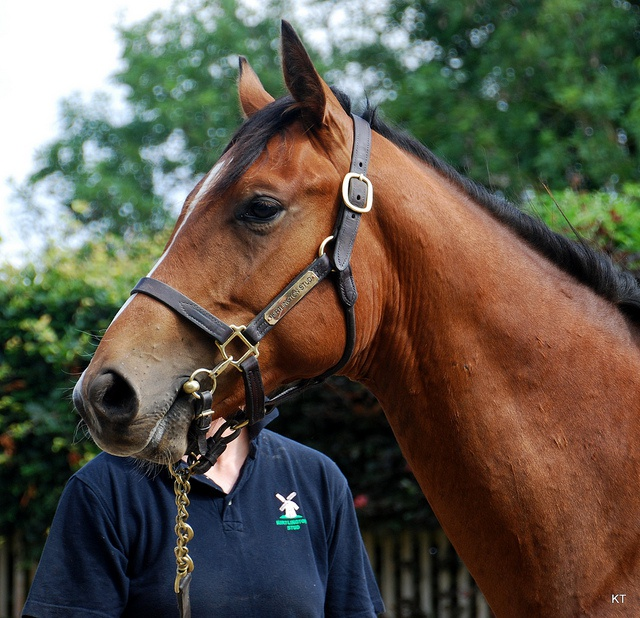Describe the objects in this image and their specific colors. I can see horse in white, black, maroon, and brown tones and people in white, black, navy, darkblue, and lightgray tones in this image. 